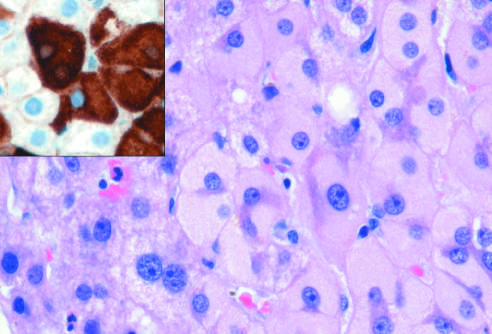s ground-glass hepatocytes in chronic hepatitis b caused by accumulation of hepatitis b surface antigen?
Answer the question using a single word or phrase. Yes 